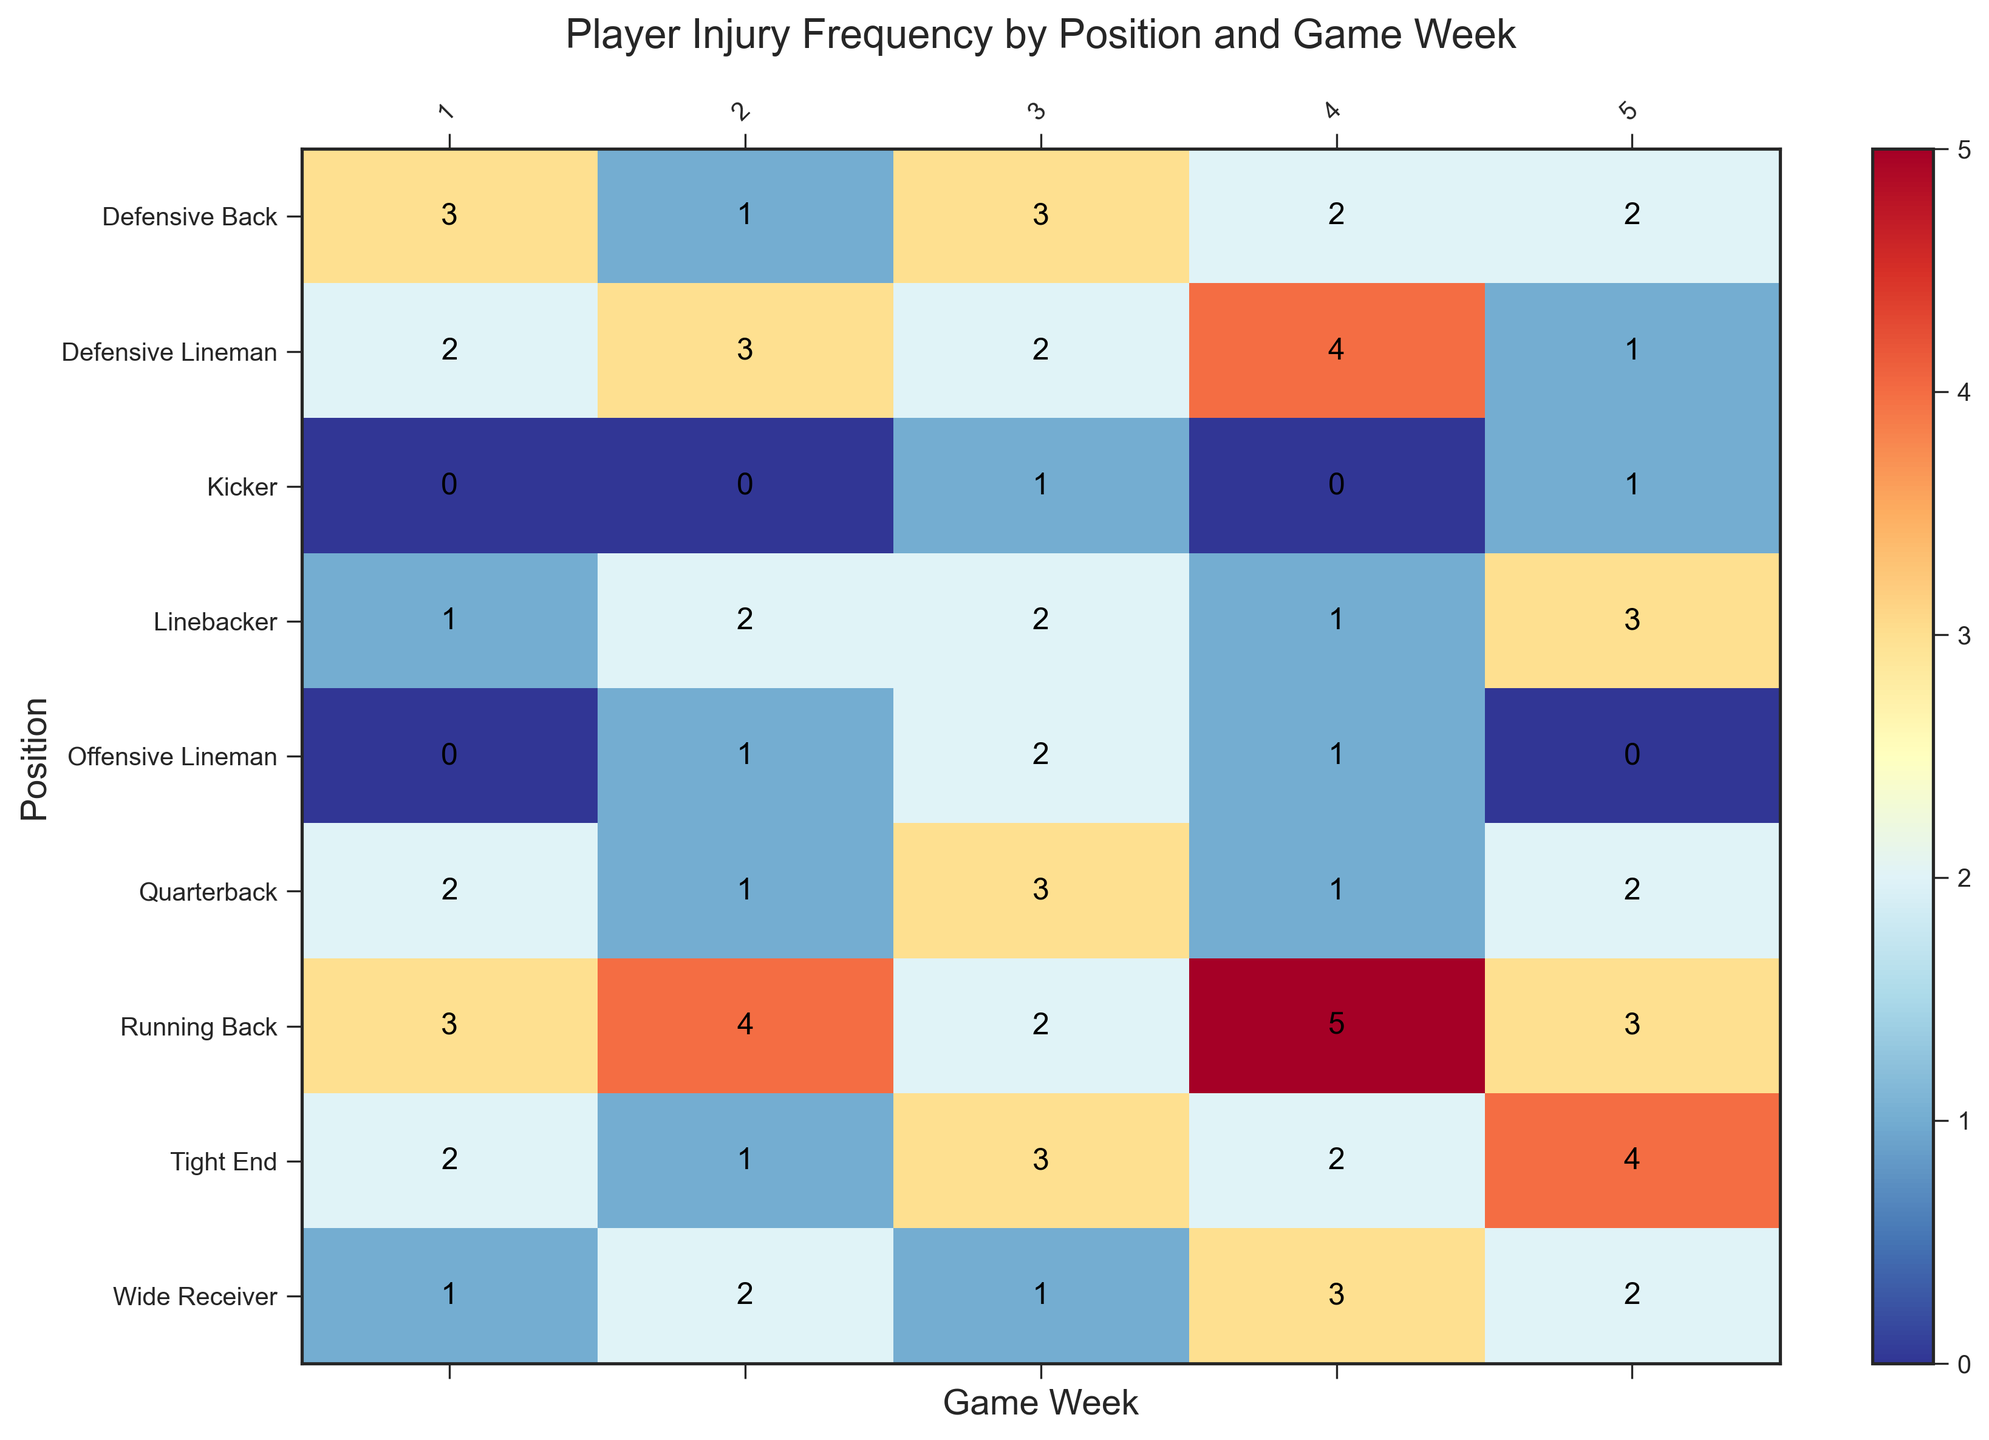Which position had the highest injury frequency in game week 4? Look at the game week 4 column and identify the row with the highest value. The Running Back position has the highest value of 5.
Answer: Running Back Which positions had a higher injury frequency in game week 3 than in game week 2? Compare the values of each position between game weeks 2 and 3. Positions where the value in week 3 is higher than in week 2 are Quarterback, Tight End, Offensive Lineman, Defensive Back, and Kicker.
Answer: Quarterback, Tight End, Offensive Lineman, Defensive Back, Kicker What is the sum of injury frequencies for Linebackers across all game weeks? Add the injury frequencies for Linebackers from game weeks 1 to 5: 1 + 2 + 2 + 1 + 3 = 9.
Answer: 9 Which position had the lowest total injury frequency across all game weeks? Calculate the total injury frequencies for each position and identify the lowest one. The Kicker has the lowest total injury frequency with 2 injuries.
Answer: Kicker How does the injury frequency for Defensive Linemen in game week 1 compare to game week 5? Look at the values for Defensive Linemen in game weeks 1 and 5. The values are 2 and 1, respectively, so the injury frequency decreased.
Answer: Decreased Which game week had the most even distribution of injury frequencies across all positions? Observe the range of values in each game week column; the week with values closest to each other is week 5, with values ranging from 0 to 4.
Answer: Week 5 What is the average injury frequency for the Wide Receiver position across the five game weeks? Sum the injury frequencies for Wide Receiver: 1 + 2 + 1 + 3 + 2 = 9, and then divide by the number of weeks: 9 / 5 = 1.8.
Answer: 1.8 Between which two consecutive game weeks did the Running Back position see the highest increase in injury frequency? Compare the differences between consecutive game weeks for Running Back: Week 2 - Week 1 (4 - 3 = 1), Week 3 - Week 2 (2 - 4 = -2), Week 4 - Week 3 (5 - 2 = 3), Week 5 - Week 4 (3 - 5 = -2). The highest increase is between game week 3 and 4.
Answer: Between game week 3 and 4 What is the total number of injuries across all positions in game week 1? Sum all the injury frequencies for game week 1: 2 + 3 + 1 + 2 + 0 + 2 + 1 + 3 + 0 = 14.
Answer: 14 